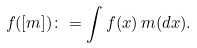<formula> <loc_0><loc_0><loc_500><loc_500>f ( [ m ] ) \colon = \int f ( x ) \, m ( d x ) .</formula> 